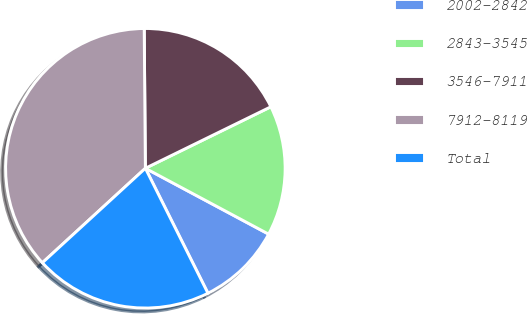Convert chart to OTSL. <chart><loc_0><loc_0><loc_500><loc_500><pie_chart><fcel>2002-2842<fcel>2843-3545<fcel>3546-7911<fcel>7912-8119<fcel>Total<nl><fcel>9.8%<fcel>15.06%<fcel>17.88%<fcel>36.68%<fcel>20.57%<nl></chart> 